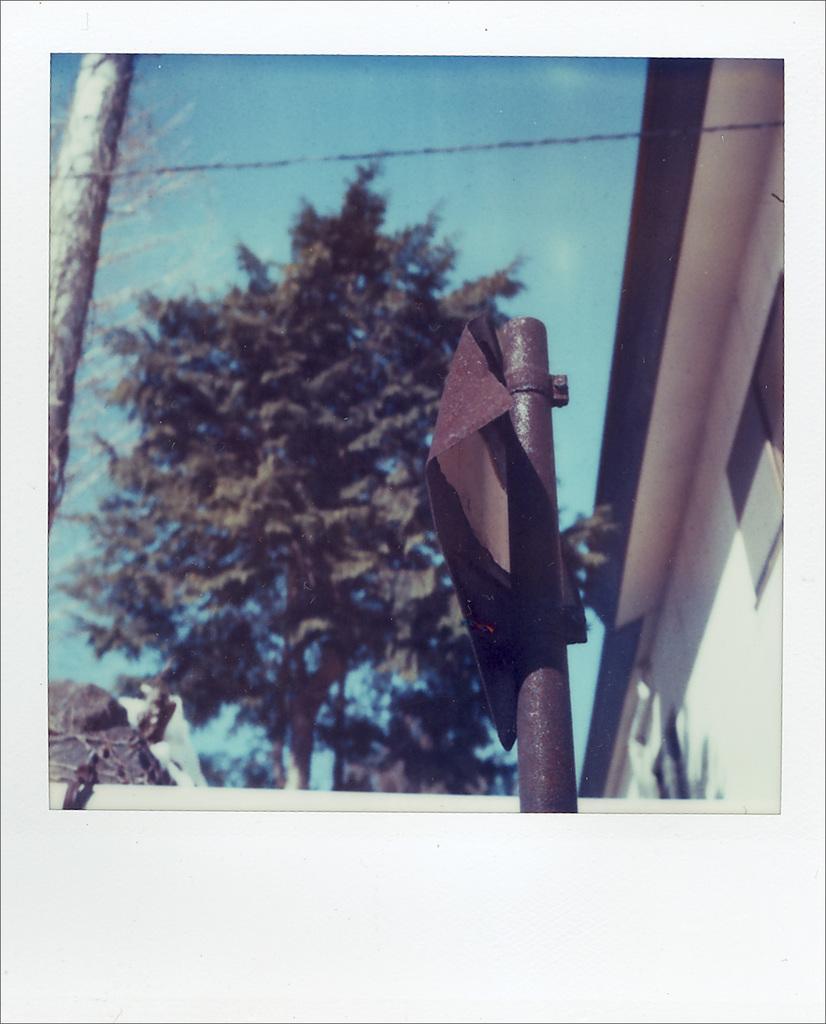Can you describe this image briefly? In this image I can see a pole, background I can see trees in green color, a building in cream color and the sky is in blue color. 